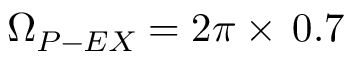<formula> <loc_0><loc_0><loc_500><loc_500>\Omega _ { P - E X } = 2 \pi \times \, 0 . 7</formula> 